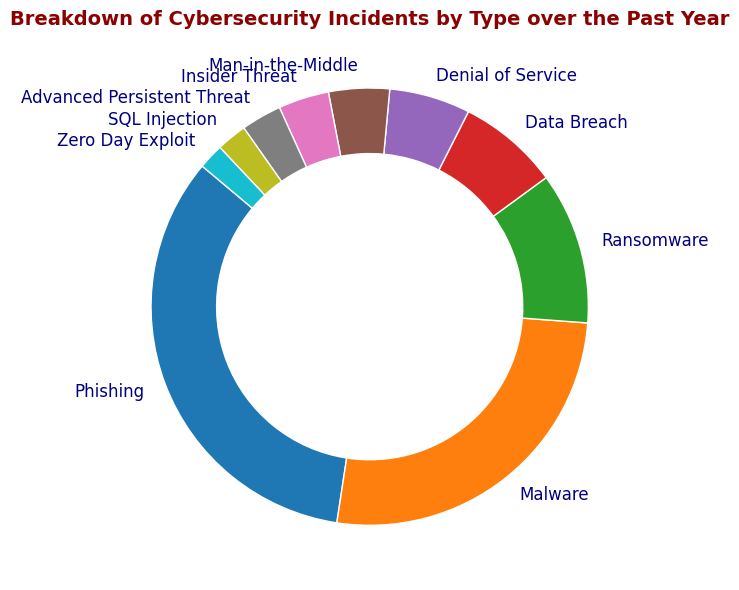What's the most common type of cybersecurity incident? The ring chart visually displays that 'Phishing' has the largest section, meaning it's the most common type of cybersecurity incident.
Answer: Phishing Which type of cybersecurity incident accounts for the smallest percentage of total incidents? The smallest section of the ring chart represents 'Zero Day Exploit', which indicates this type has the lowest count relative to others.
Answer: Zero Day Exploit What is the combined percentage of Malware and Phishing incidents? The chart shows percentages for each incident type: Phishing 45% and Malware 35%. Adding these gives 45% + 35% = 80%.
Answer: 80% How many combined incidents are there of Insider Threat and Man-in-the-Middle? The counts for Insider Threat and Man-in-the-Middle are 50 and 60 respectively. Adding these gives 50 + 60 = 110.
Answer: 110 Does Ransomware appear more frequently than Data Breach incidents? By looking at the sections of the ring chart, 'Ransomware' has a larger section than 'Data Breach', which indicates it occurs more frequently.
Answer: Yes What is the percentage difference between Denial of Service and SQL Injection incidents? Denial of Service is 8% and SQL Injection is 3%. The percentage difference is 8% - 3% = 5%.
Answer: 5% If you combine the counts of Advanced Persistent Threat and Zero Day Exploit incidents, do they make up more than 5% of the total incidents? Advanced Persistent Threat has 40 incidents and Zero Day Exploit has 25. Combining these gives 40 + 25 = 65. The total incidents are 1335 (from all counts). The percentage is (65/1335) * 100 ≈ 4.9%, which is slightly below 5%.
Answer: No Which incidents have a percentage greater than 10%? From the ring chart, incidents with patches larger than 10% are 'Phishing' and 'Malware'.
Answer: Phishing, Malware 